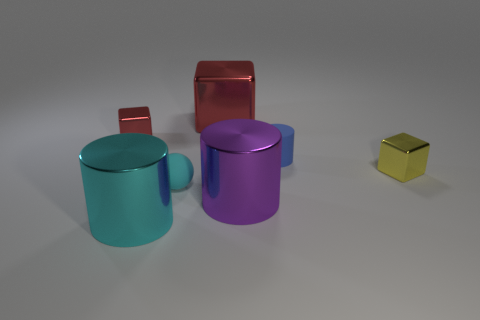Subtract all blue matte cylinders. How many cylinders are left? 2 Add 1 green shiny cylinders. How many objects exist? 8 Subtract all blue cylinders. How many cylinders are left? 2 Subtract 2 cylinders. How many cylinders are left? 1 Subtract all gray balls. Subtract all green cylinders. How many balls are left? 1 Subtract all red cylinders. How many gray cubes are left? 0 Subtract all tiny yellow shiny spheres. Subtract all small things. How many objects are left? 3 Add 3 big purple cylinders. How many big purple cylinders are left? 4 Add 5 yellow metallic blocks. How many yellow metallic blocks exist? 6 Subtract 0 blue spheres. How many objects are left? 7 